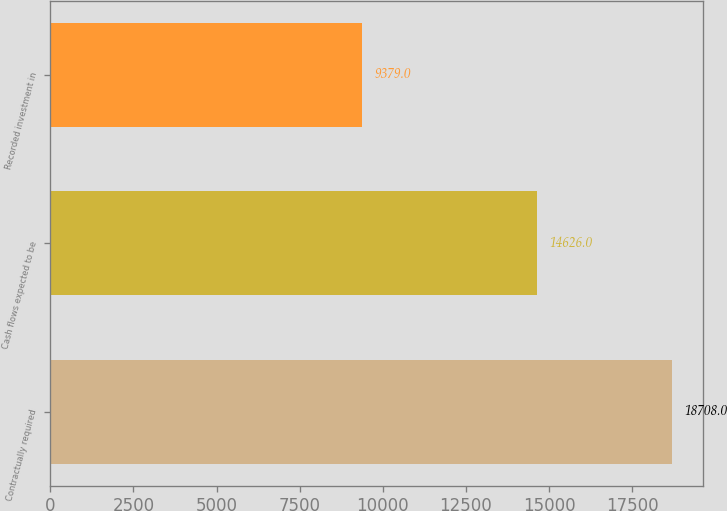<chart> <loc_0><loc_0><loc_500><loc_500><bar_chart><fcel>Contractually required<fcel>Cash flows expected to be<fcel>Recorded investment in<nl><fcel>18708<fcel>14626<fcel>9379<nl></chart> 